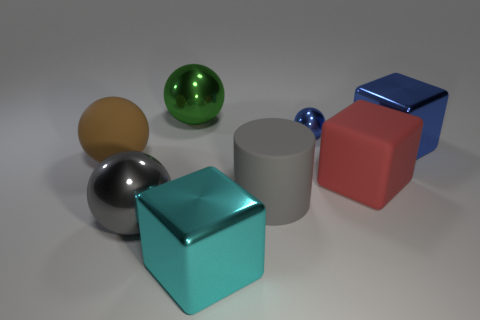Which object stands out the most and why? The cyan metallic cube stands out the most because of its vibrant color, central positioning, and reflective surface which catches the lighting notably compared to the other objects. How does the lighting affect the appearance of the objects? The lighting in the image creates distinct highlights and shadows on the objects. It enhances the reflectivity and texture differences between the materials, giving a sense of depth and realism to the scene. 